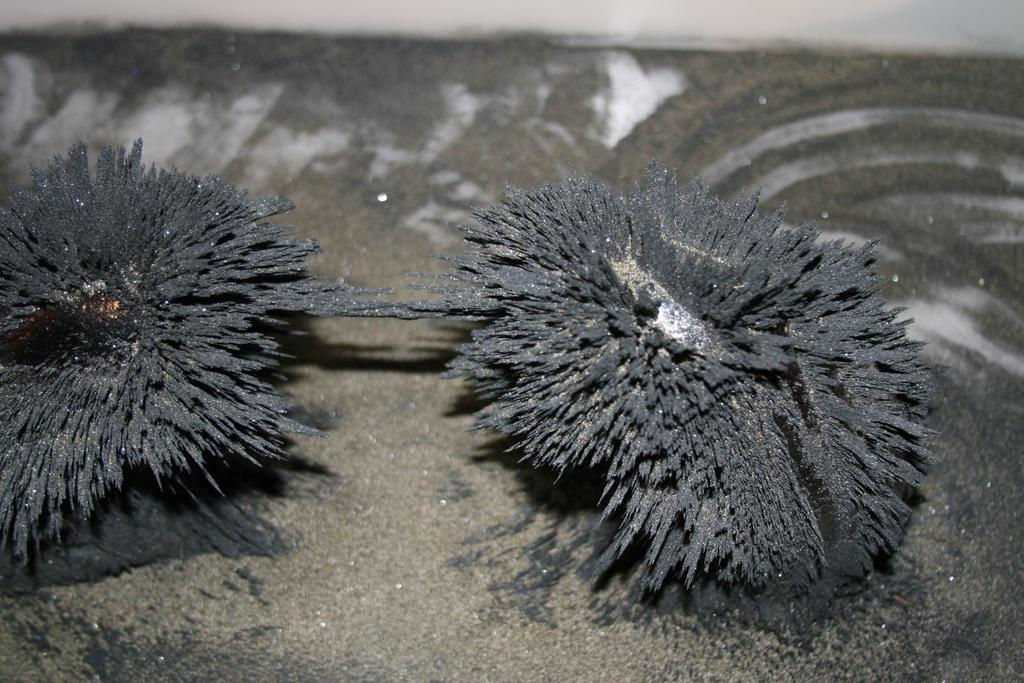What is the main object in the image? There is a magnet in the image. What color is the other object in the image? There is a black color object in the image. How are the two objects related in the image? The black color object is sticking to the magnet. What is the color of the surface on which the objects are placed? The objects are on an ash color surface. How many eyes does the cushion have in the image? There is no cushion present in the image, so it is not possible to determine the number of eyes it might have. 